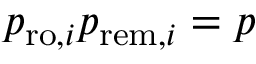Convert formula to latex. <formula><loc_0><loc_0><loc_500><loc_500>p _ { r o , i } p _ { r e m , i } = p</formula> 